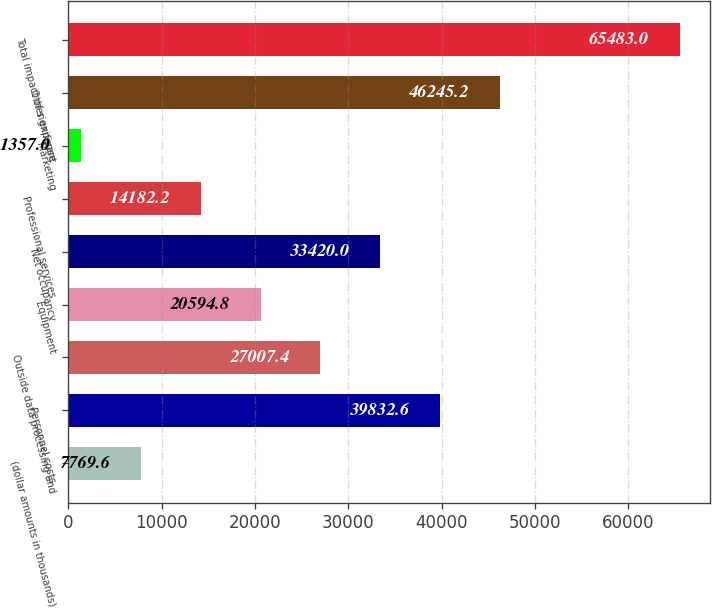Convert chart to OTSL. <chart><loc_0><loc_0><loc_500><loc_500><bar_chart><fcel>(dollar amounts in thousands)<fcel>Personnel costs<fcel>Outside data processing and<fcel>Equipment<fcel>Net occupancy<fcel>Professional services<fcel>Marketing<fcel>Other expense<fcel>Total impact of significant<nl><fcel>7769.6<fcel>39832.6<fcel>27007.4<fcel>20594.8<fcel>33420<fcel>14182.2<fcel>1357<fcel>46245.2<fcel>65483<nl></chart> 